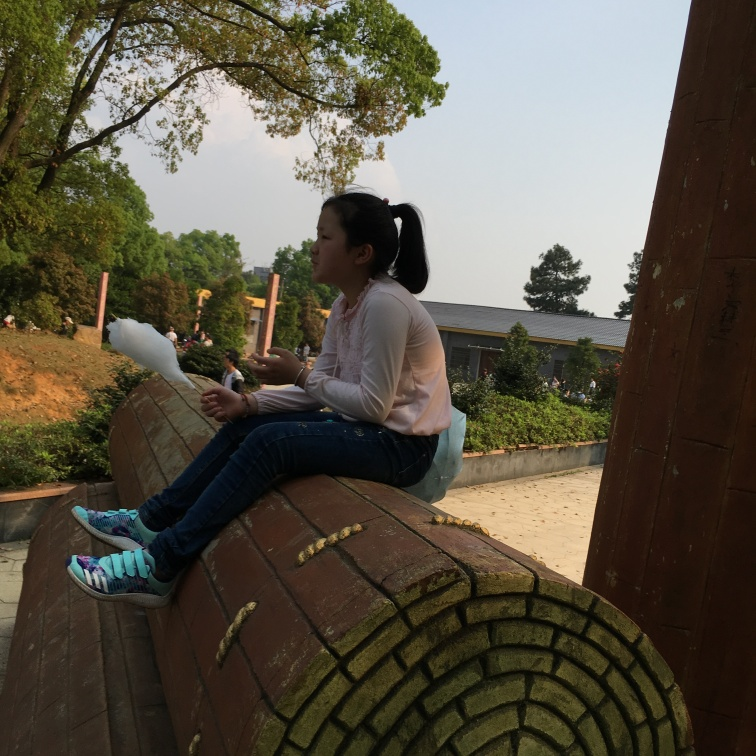How might the weather on that day be described based on the image? The weather appears to be mild and pleasant, as suggested by the subject's light clothing and the presence of sunlit areas. There are no indications of extreme weather conditions like rain or snow, and the foliage looks verdant, fitting for a bright spring or early fall day. 